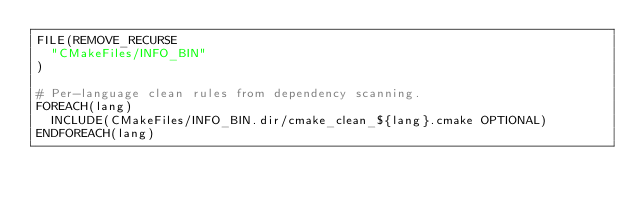<code> <loc_0><loc_0><loc_500><loc_500><_CMake_>FILE(REMOVE_RECURSE
  "CMakeFiles/INFO_BIN"
)

# Per-language clean rules from dependency scanning.
FOREACH(lang)
  INCLUDE(CMakeFiles/INFO_BIN.dir/cmake_clean_${lang}.cmake OPTIONAL)
ENDFOREACH(lang)
</code> 